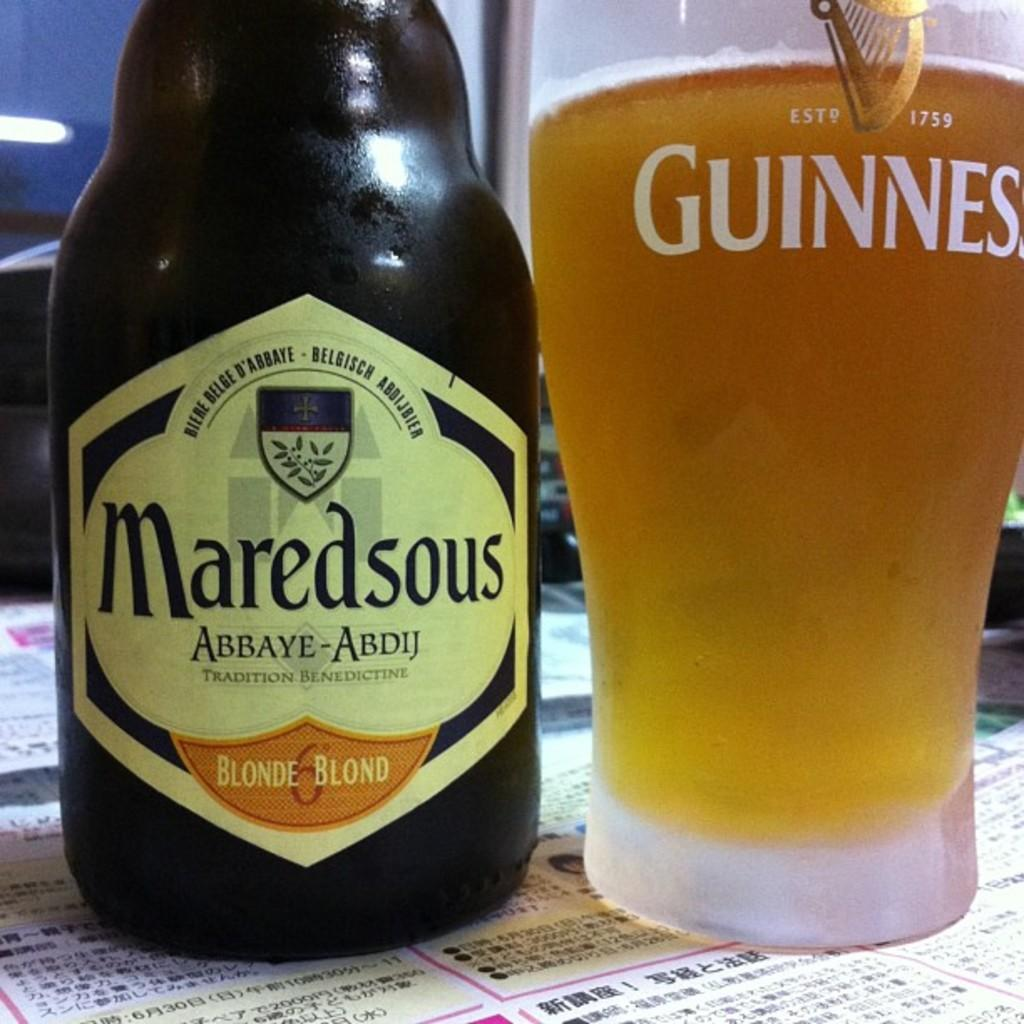What is in the bottle that is visible in the image? There is a bottle with a label in the image. What is in the glass that is visible in the image? There is a glass with liquid in the image. What type of items are on the posters in the image? The posters in the image have text on them. What can be seen behind the objects in the image? The background is visible in the image. How many wounds can be seen on the bottle in the image? There are no wounds present on the bottle in the image. What stage of development is the can in the image? There is no can present in the image. 